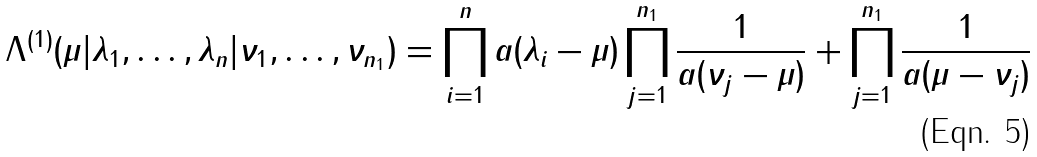Convert formula to latex. <formula><loc_0><loc_0><loc_500><loc_500>\Lambda ^ { ( 1 ) } ( \mu | \lambda _ { 1 } , \dots , \lambda _ { n } | \nu _ { 1 } , \dots , \nu _ { n _ { 1 } } ) = \prod _ { i = 1 } ^ { n } a ( \lambda _ { i } - \mu ) \prod _ { j = 1 } ^ { n _ { 1 } } \frac { 1 } { a ( \nu _ { j } - \mu ) } + \prod _ { j = 1 } ^ { n _ { 1 } } \frac { 1 } { a ( \mu - \nu _ { j } ) }</formula> 